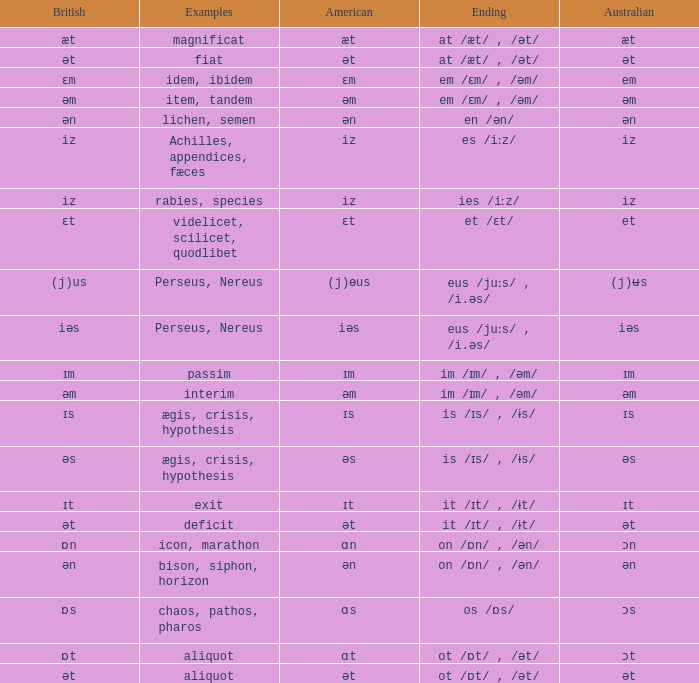Which British has Examples of exit? Ɪt. 